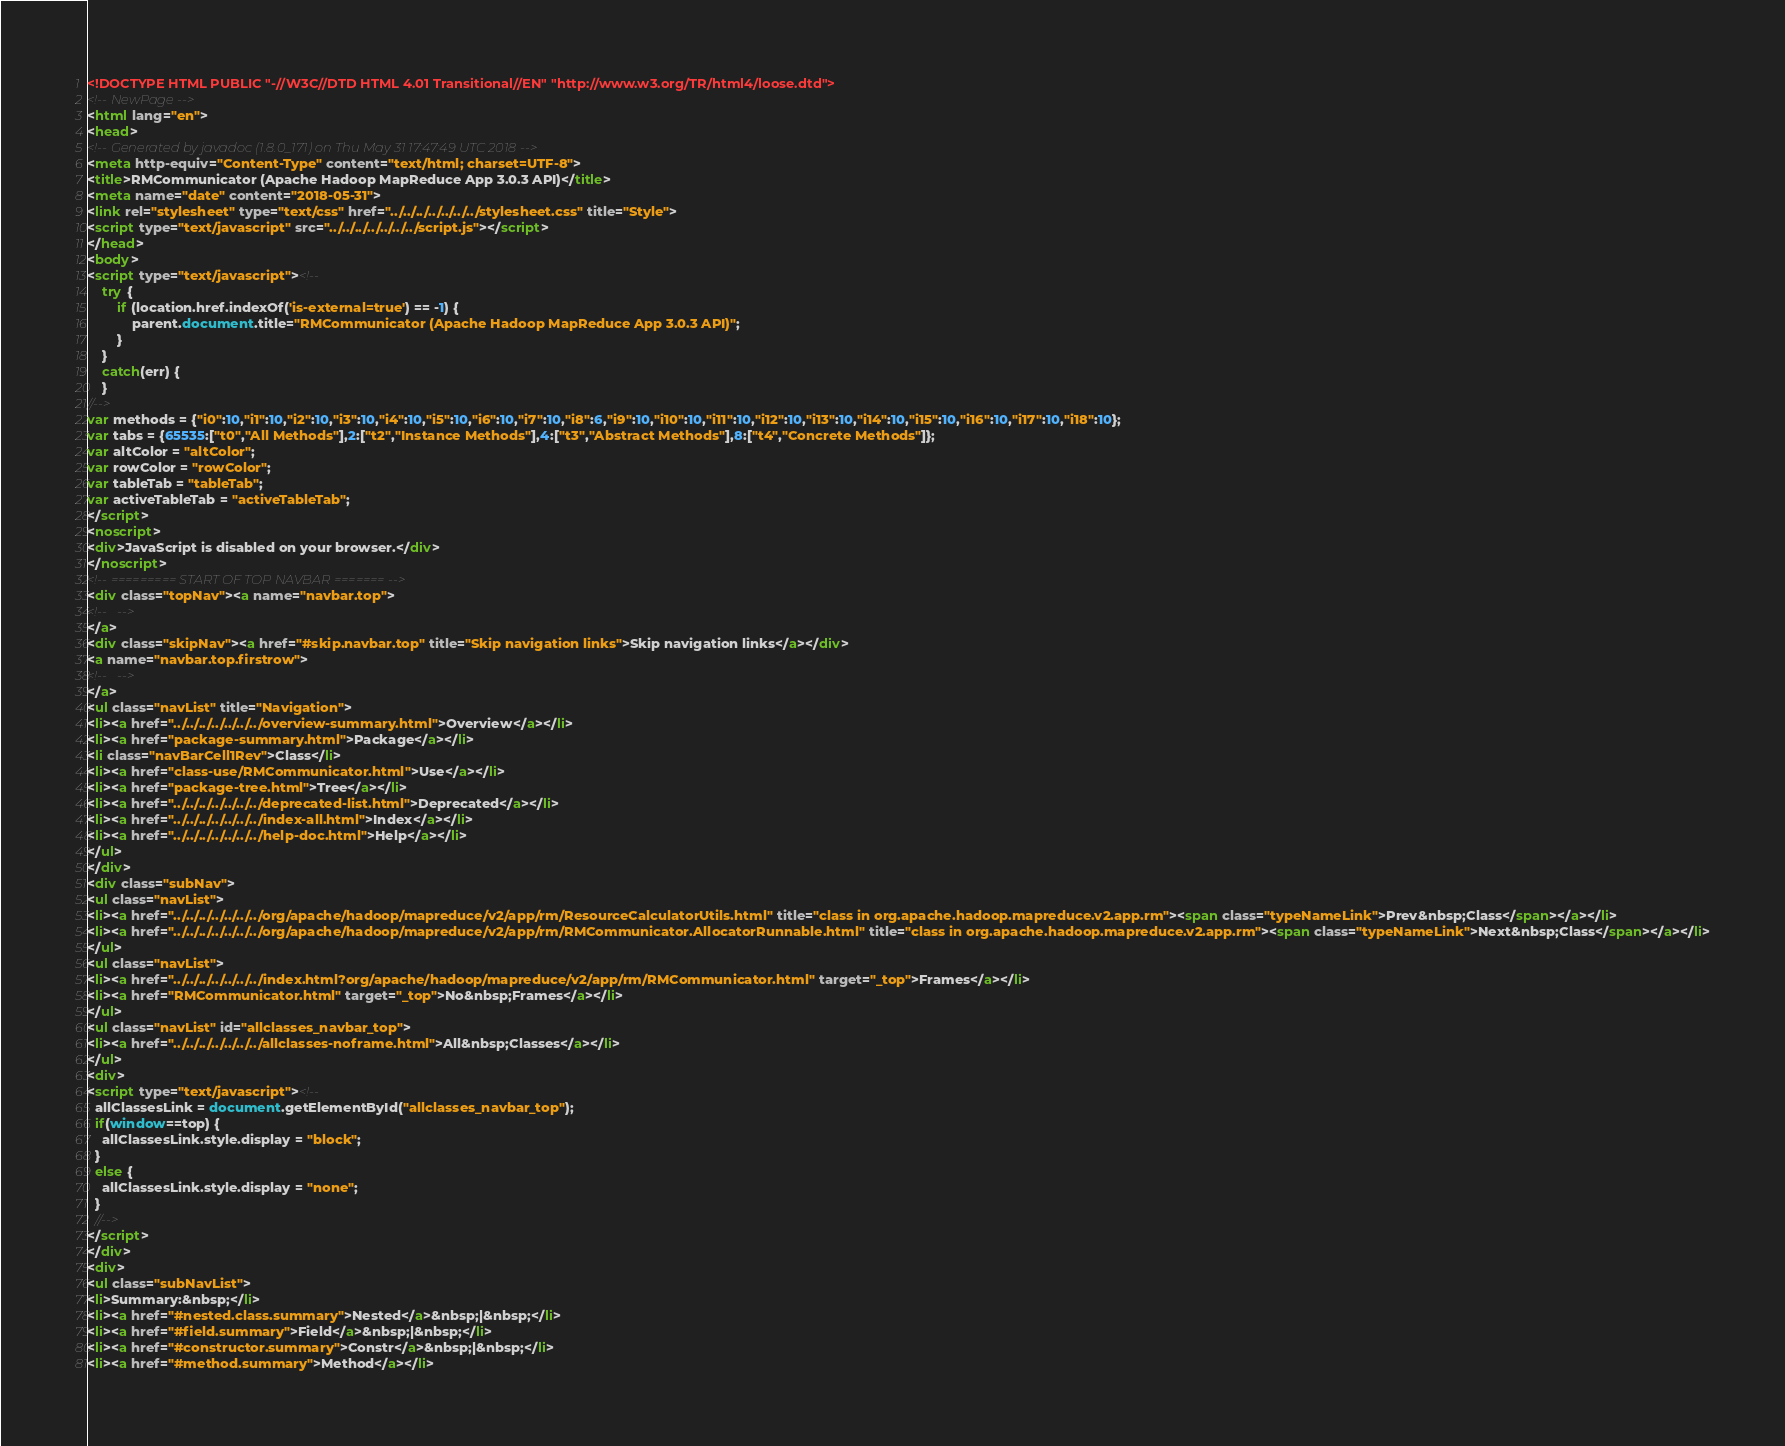Convert code to text. <code><loc_0><loc_0><loc_500><loc_500><_HTML_><!DOCTYPE HTML PUBLIC "-//W3C//DTD HTML 4.01 Transitional//EN" "http://www.w3.org/TR/html4/loose.dtd">
<!-- NewPage -->
<html lang="en">
<head>
<!-- Generated by javadoc (1.8.0_171) on Thu May 31 17:47:49 UTC 2018 -->
<meta http-equiv="Content-Type" content="text/html; charset=UTF-8">
<title>RMCommunicator (Apache Hadoop MapReduce App 3.0.3 API)</title>
<meta name="date" content="2018-05-31">
<link rel="stylesheet" type="text/css" href="../../../../../../../stylesheet.css" title="Style">
<script type="text/javascript" src="../../../../../../../script.js"></script>
</head>
<body>
<script type="text/javascript"><!--
    try {
        if (location.href.indexOf('is-external=true') == -1) {
            parent.document.title="RMCommunicator (Apache Hadoop MapReduce App 3.0.3 API)";
        }
    }
    catch(err) {
    }
//-->
var methods = {"i0":10,"i1":10,"i2":10,"i3":10,"i4":10,"i5":10,"i6":10,"i7":10,"i8":6,"i9":10,"i10":10,"i11":10,"i12":10,"i13":10,"i14":10,"i15":10,"i16":10,"i17":10,"i18":10};
var tabs = {65535:["t0","All Methods"],2:["t2","Instance Methods"],4:["t3","Abstract Methods"],8:["t4","Concrete Methods"]};
var altColor = "altColor";
var rowColor = "rowColor";
var tableTab = "tableTab";
var activeTableTab = "activeTableTab";
</script>
<noscript>
<div>JavaScript is disabled on your browser.</div>
</noscript>
<!-- ========= START OF TOP NAVBAR ======= -->
<div class="topNav"><a name="navbar.top">
<!--   -->
</a>
<div class="skipNav"><a href="#skip.navbar.top" title="Skip navigation links">Skip navigation links</a></div>
<a name="navbar.top.firstrow">
<!--   -->
</a>
<ul class="navList" title="Navigation">
<li><a href="../../../../../../../overview-summary.html">Overview</a></li>
<li><a href="package-summary.html">Package</a></li>
<li class="navBarCell1Rev">Class</li>
<li><a href="class-use/RMCommunicator.html">Use</a></li>
<li><a href="package-tree.html">Tree</a></li>
<li><a href="../../../../../../../deprecated-list.html">Deprecated</a></li>
<li><a href="../../../../../../../index-all.html">Index</a></li>
<li><a href="../../../../../../../help-doc.html">Help</a></li>
</ul>
</div>
<div class="subNav">
<ul class="navList">
<li><a href="../../../../../../../org/apache/hadoop/mapreduce/v2/app/rm/ResourceCalculatorUtils.html" title="class in org.apache.hadoop.mapreduce.v2.app.rm"><span class="typeNameLink">Prev&nbsp;Class</span></a></li>
<li><a href="../../../../../../../org/apache/hadoop/mapreduce/v2/app/rm/RMCommunicator.AllocatorRunnable.html" title="class in org.apache.hadoop.mapreduce.v2.app.rm"><span class="typeNameLink">Next&nbsp;Class</span></a></li>
</ul>
<ul class="navList">
<li><a href="../../../../../../../index.html?org/apache/hadoop/mapreduce/v2/app/rm/RMCommunicator.html" target="_top">Frames</a></li>
<li><a href="RMCommunicator.html" target="_top">No&nbsp;Frames</a></li>
</ul>
<ul class="navList" id="allclasses_navbar_top">
<li><a href="../../../../../../../allclasses-noframe.html">All&nbsp;Classes</a></li>
</ul>
<div>
<script type="text/javascript"><!--
  allClassesLink = document.getElementById("allclasses_navbar_top");
  if(window==top) {
    allClassesLink.style.display = "block";
  }
  else {
    allClassesLink.style.display = "none";
  }
  //-->
</script>
</div>
<div>
<ul class="subNavList">
<li>Summary:&nbsp;</li>
<li><a href="#nested.class.summary">Nested</a>&nbsp;|&nbsp;</li>
<li><a href="#field.summary">Field</a>&nbsp;|&nbsp;</li>
<li><a href="#constructor.summary">Constr</a>&nbsp;|&nbsp;</li>
<li><a href="#method.summary">Method</a></li></code> 